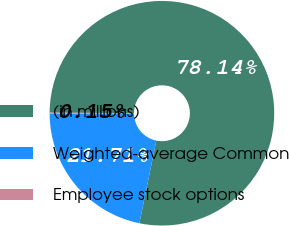<chart> <loc_0><loc_0><loc_500><loc_500><pie_chart><fcel>(in millions)<fcel>Weighted-average Common<fcel>Employee stock options<nl><fcel>78.14%<fcel>21.71%<fcel>0.15%<nl></chart> 